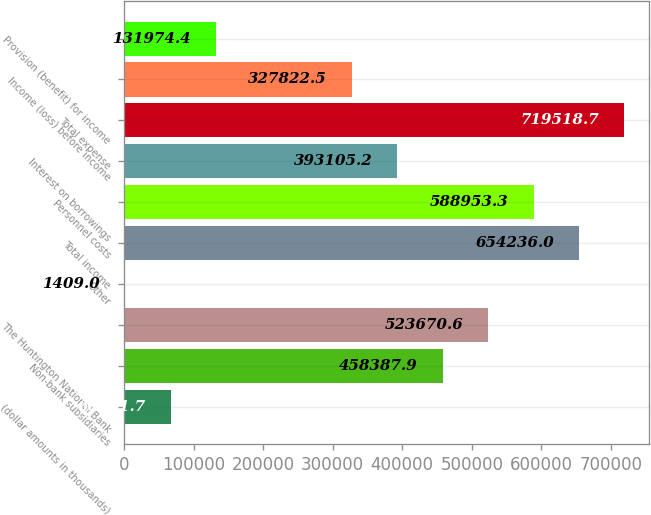<chart> <loc_0><loc_0><loc_500><loc_500><bar_chart><fcel>(dollar amounts in thousands)<fcel>Non-bank subsidiaries<fcel>The Huntington National Bank<fcel>Other<fcel>Total income<fcel>Personnel costs<fcel>Interest on borrowings<fcel>Total expense<fcel>Income (loss) before income<fcel>Provision (benefit) for income<nl><fcel>66691.7<fcel>458388<fcel>523671<fcel>1409<fcel>654236<fcel>588953<fcel>393105<fcel>719519<fcel>327822<fcel>131974<nl></chart> 